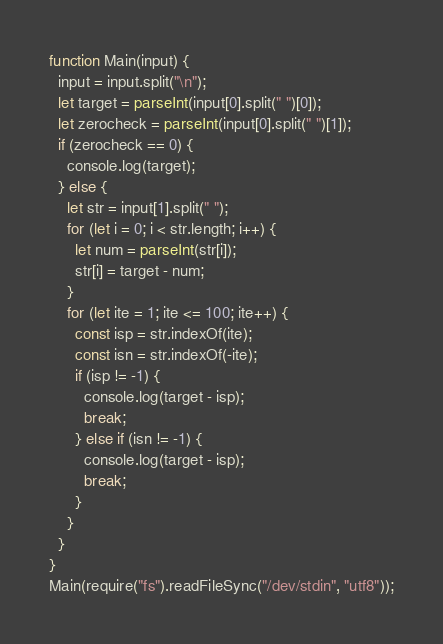Convert code to text. <code><loc_0><loc_0><loc_500><loc_500><_JavaScript_>function Main(input) {
  input = input.split("\n");
  let target = parseInt(input[0].split(" ")[0]);
  let zerocheck = parseInt(input[0].split(" ")[1]);
  if (zerocheck == 0) {
    console.log(target);
  } else {
    let str = input[1].split(" ");
    for (let i = 0; i < str.length; i++) {
      let num = parseInt(str[i]);
      str[i] = target - num;
    }
    for (let ite = 1; ite <= 100; ite++) {
      const isp = str.indexOf(ite);
      const isn = str.indexOf(-ite);
      if (isp != -1) {
        console.log(target - isp);
        break;
      } else if (isn != -1) {
        console.log(target - isp);
        break;
      }
    }
  }
}
Main(require("fs").readFileSync("/dev/stdin", "utf8"));</code> 